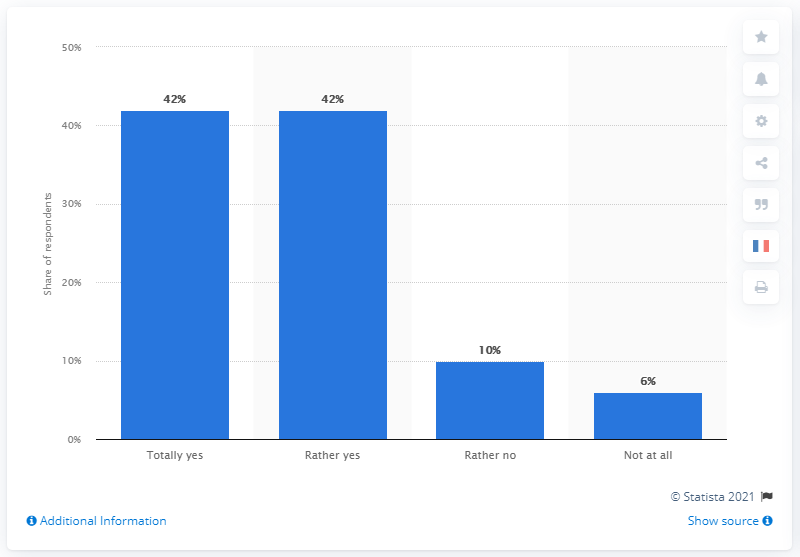Mention a couple of crucial points in this snapshot. The result of dividing the "Totally yes" bar by the "Rather no" bar is not greater than the "Not at all" bar. The rightmost bar has a percentage value of 6. 